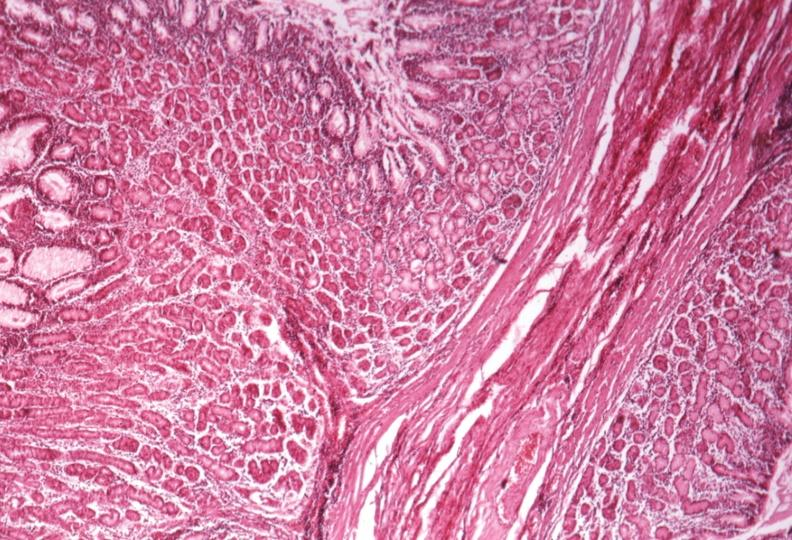s cystadenocarcinoma malignancy present?
Answer the question using a single word or phrase. No 